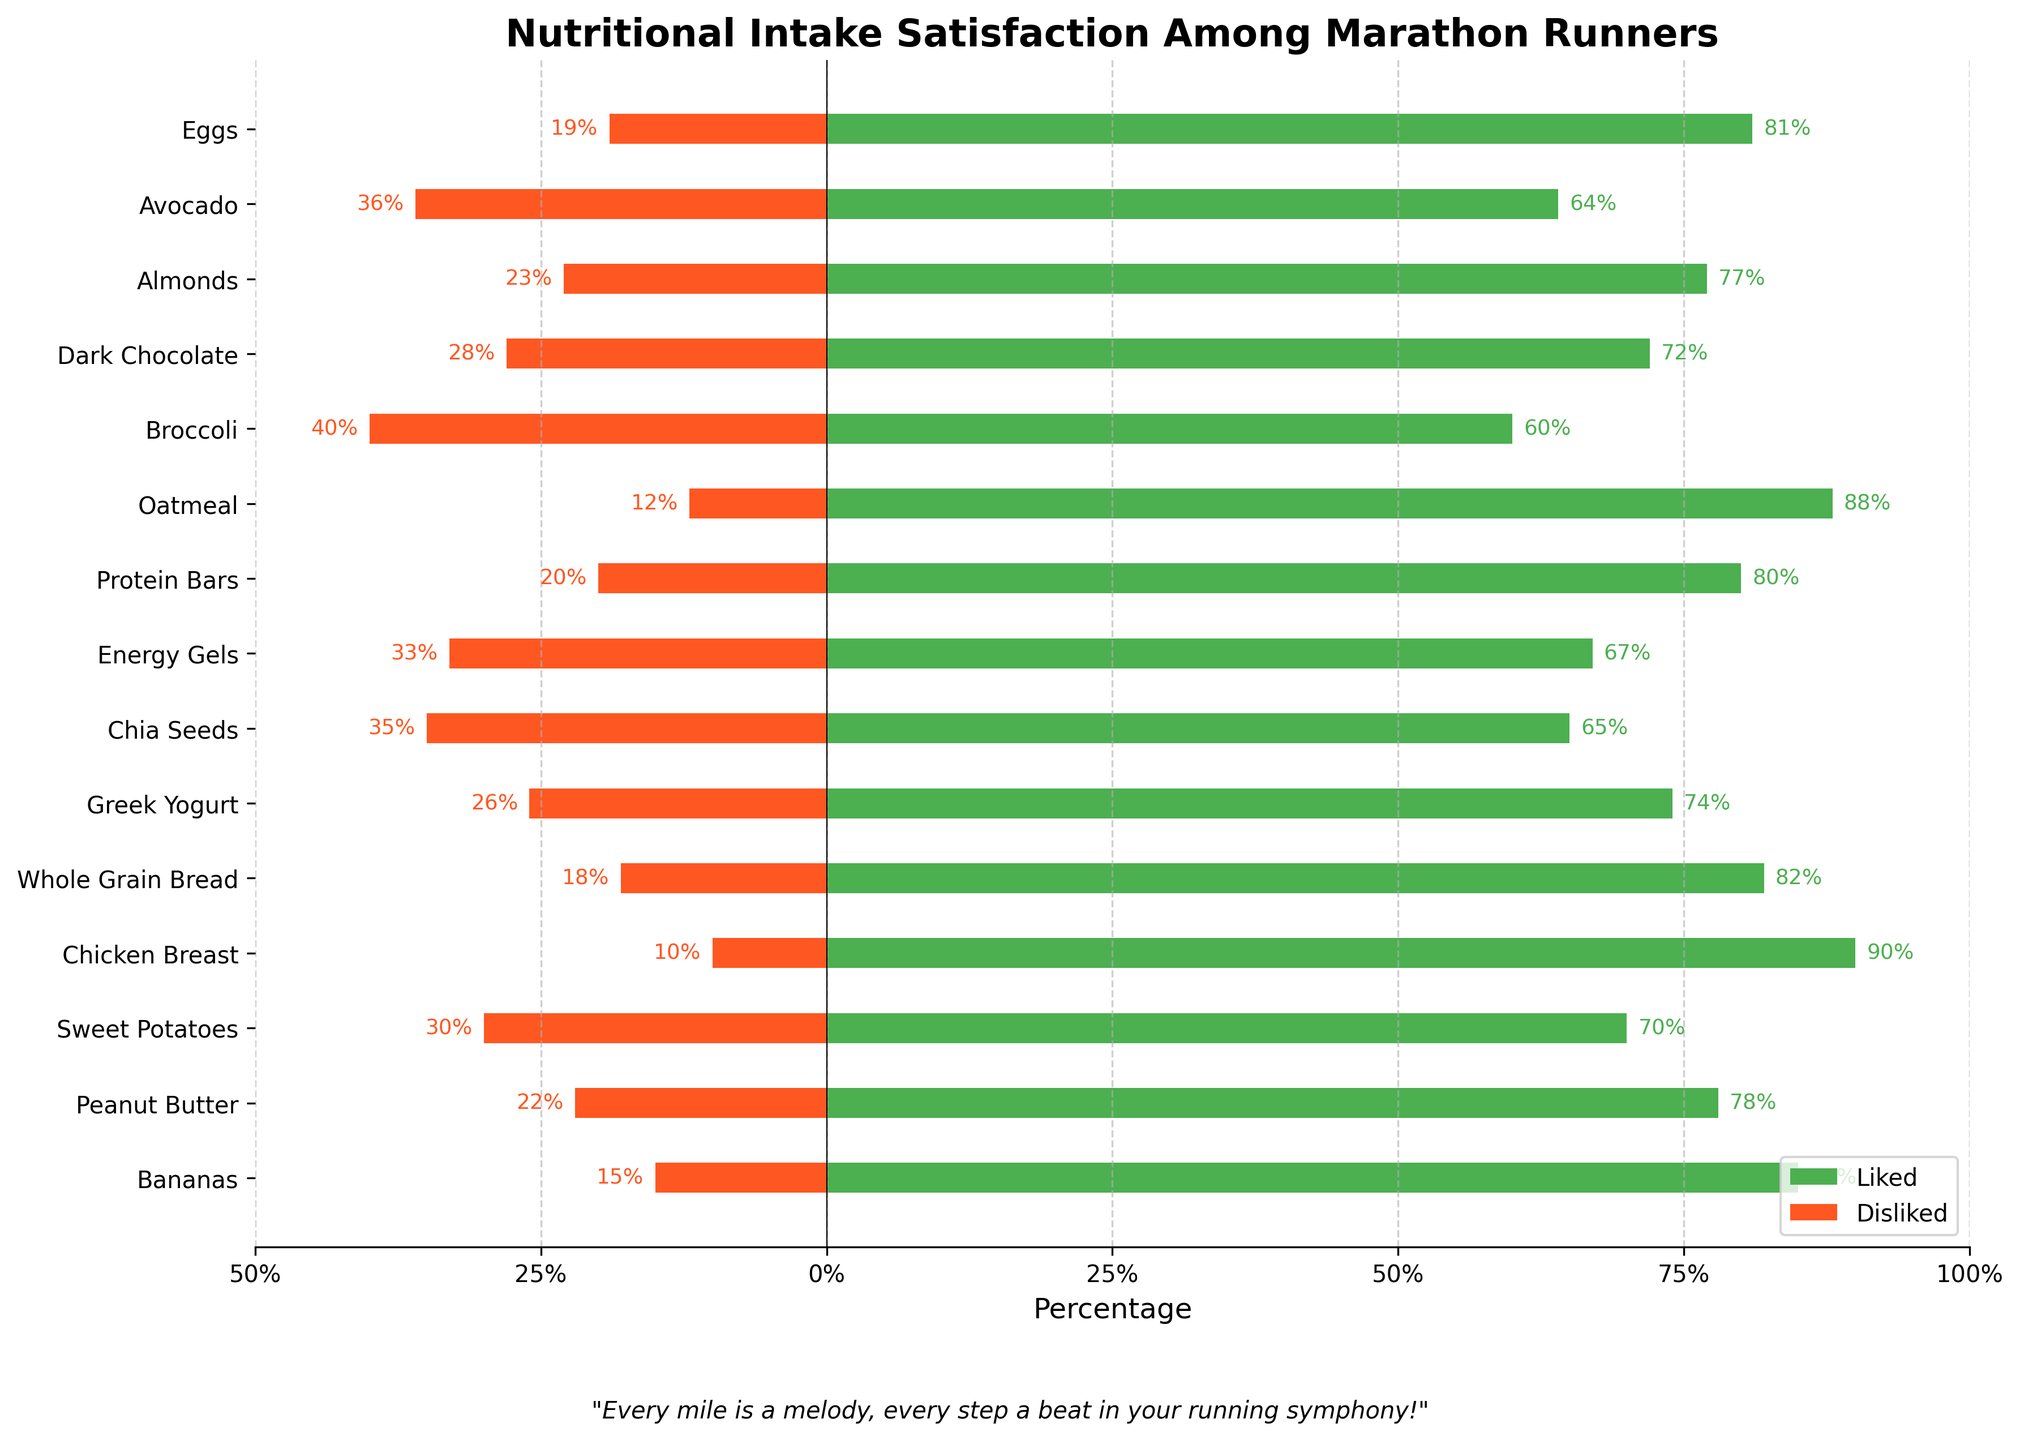Which food has the highest percentage of likes? Identify the tallest green bar in the plot. The green bar for Chicken Breast is the highest at 90%.
Answer: Chicken Breast Which food has the highest percentage of dislikes? Identify the longest red bar in the plot. The red bar for Broccoli is the longest with negative -40%.
Answer: Broccoli What's the combined percentage for likes and dislikes of Bananas? Add the liked and disliked percentages for Bananas: 85% (liked) + 15% (disliked) = 100%.
Answer: 100% Which food is more liked: Energy Gels or Greek Yogurt? Compare the heights of the green bars for both foods. The green bar for Greek Yogurt is at 74%, and for Energy Gels, it is at 67%. Therefore, Greek Yogurt is more liked.
Answer: Greek Yogurt What is the difference in the percentage of likes between Peanut Butter and Protein Bars? Subtract the percentage of likes for Protein Bars from Peanut Butter: 78% (Peanut Butter) - 80% (Protein Bars) = -2%.
Answer: -2% Name two foods with a dislike percentage of more than 30%. Identify foods with red bars larger than -30%. Chia Seeds have a disliked percentage of 35%, and Broccoli has 40%.
Answer: Chia Seeds and Broccoli Which food has a higher dislike percentage, Dark Chocolate or Avocado? Compare the length of the red bars for both foods. Dark Chocolate has a disliked percentage of 28%, and Avocado has 36%. Hence, Avocado has a higher percentage of dislikes.
Answer: Avocado What's the average percentage of likes for Bananas, Sweet Potatoes, and Oatmeal? Add the liked percentages and divide by the number of items: (85 + 70 + 88) / 3 = 81%.
Answer: 81% What is the total percentage of dislikes for Chicken Breast and Almonds? Add the disliked percentages of both foods: 10% (Chicken Breast) + 23% (Almonds) = 33%.
Answer: 33% Which food has more balanced percentages of likes and dislikes, based on the visual length of the bars? Identify food with green (like) and red (dislike) bars that are nearly equal in length. The bars for Greek Yogurt show close to balanced percentages with 74% liked and 26% disliked.
Answer: Greek Yogurt 